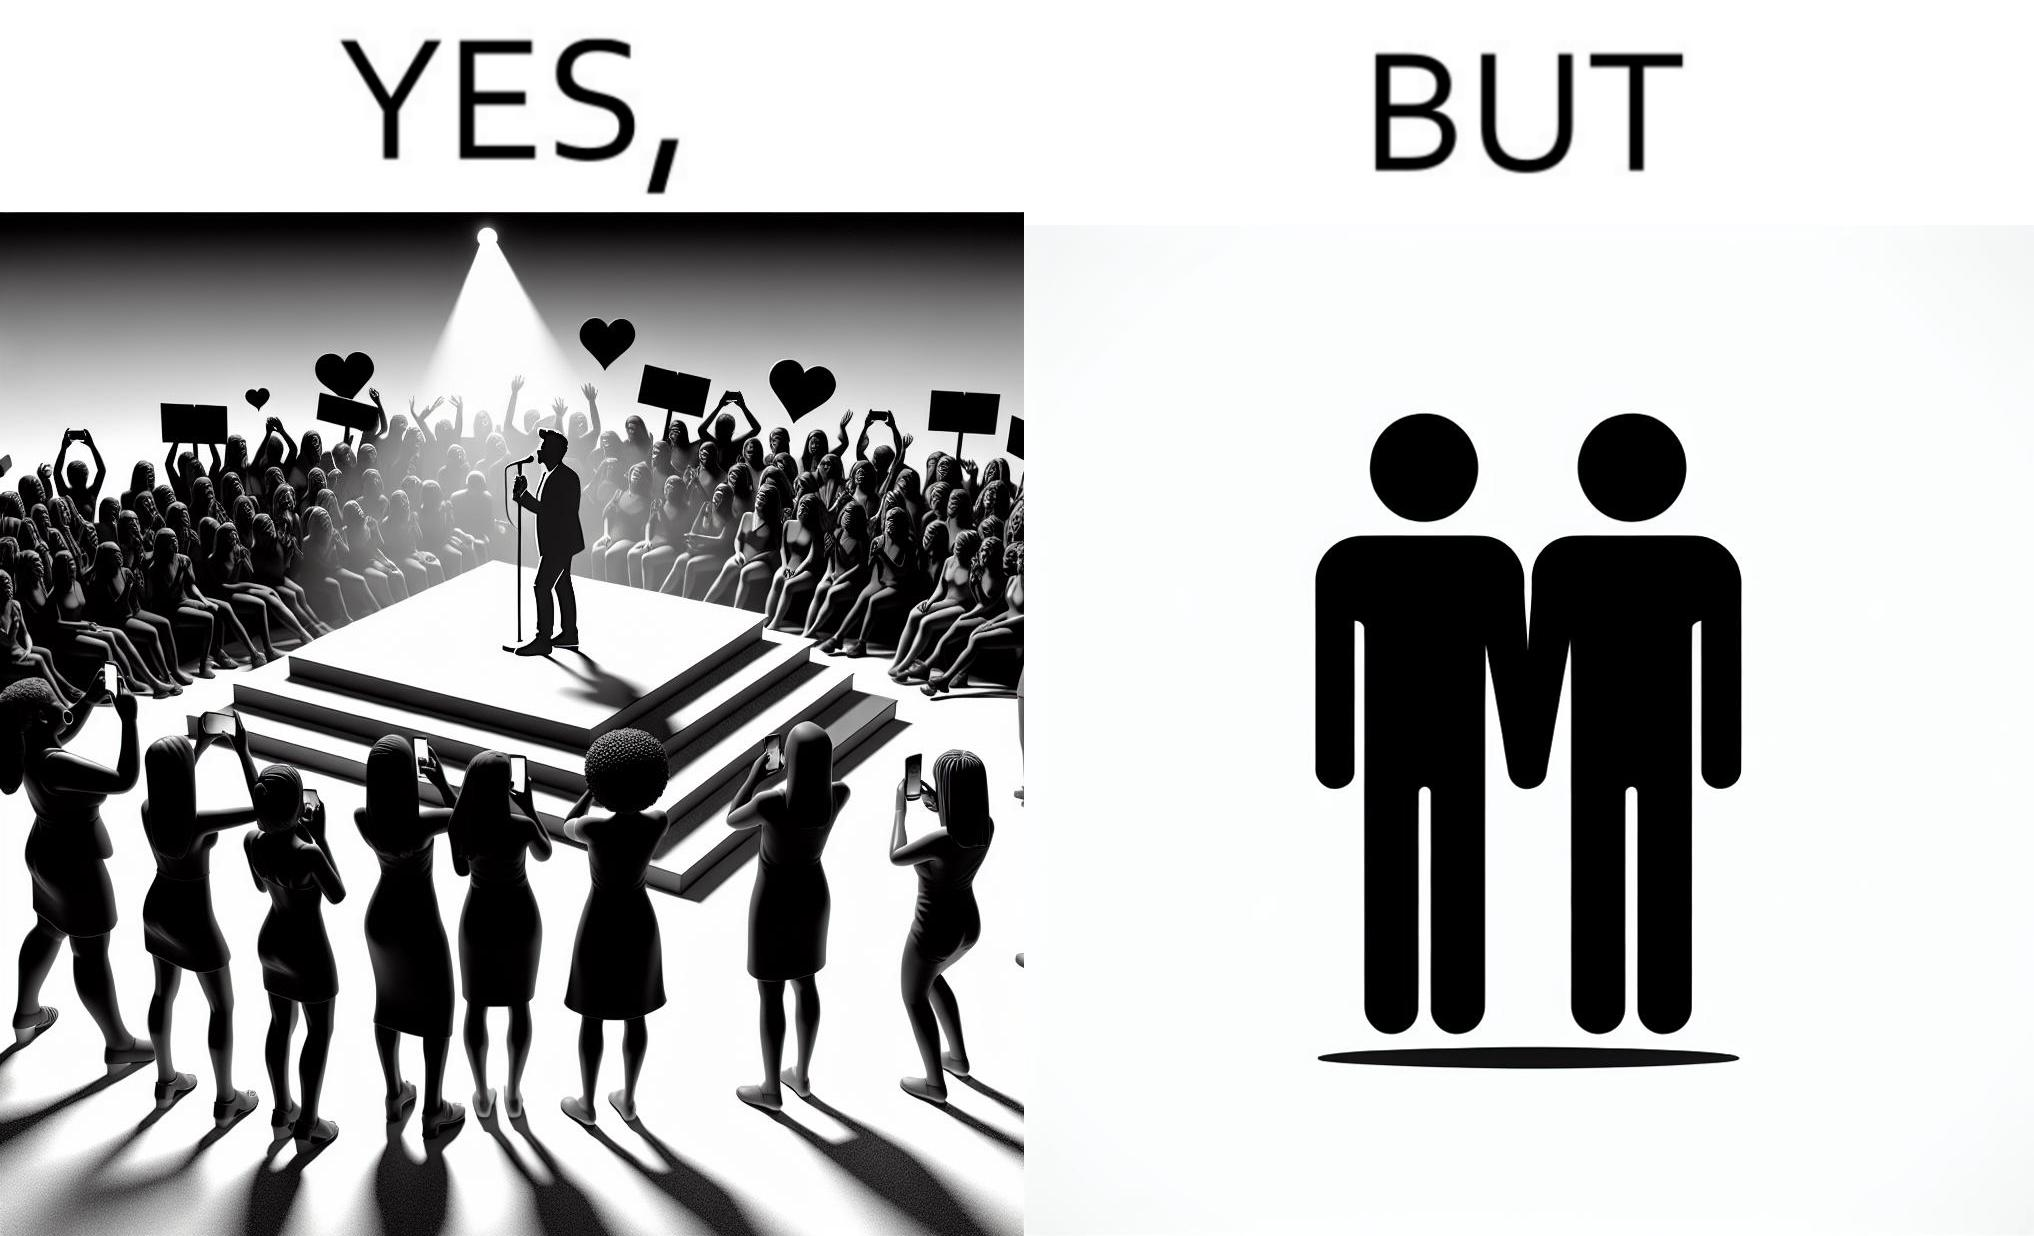Would you classify this image as satirical? Yes, this image is satirical. 